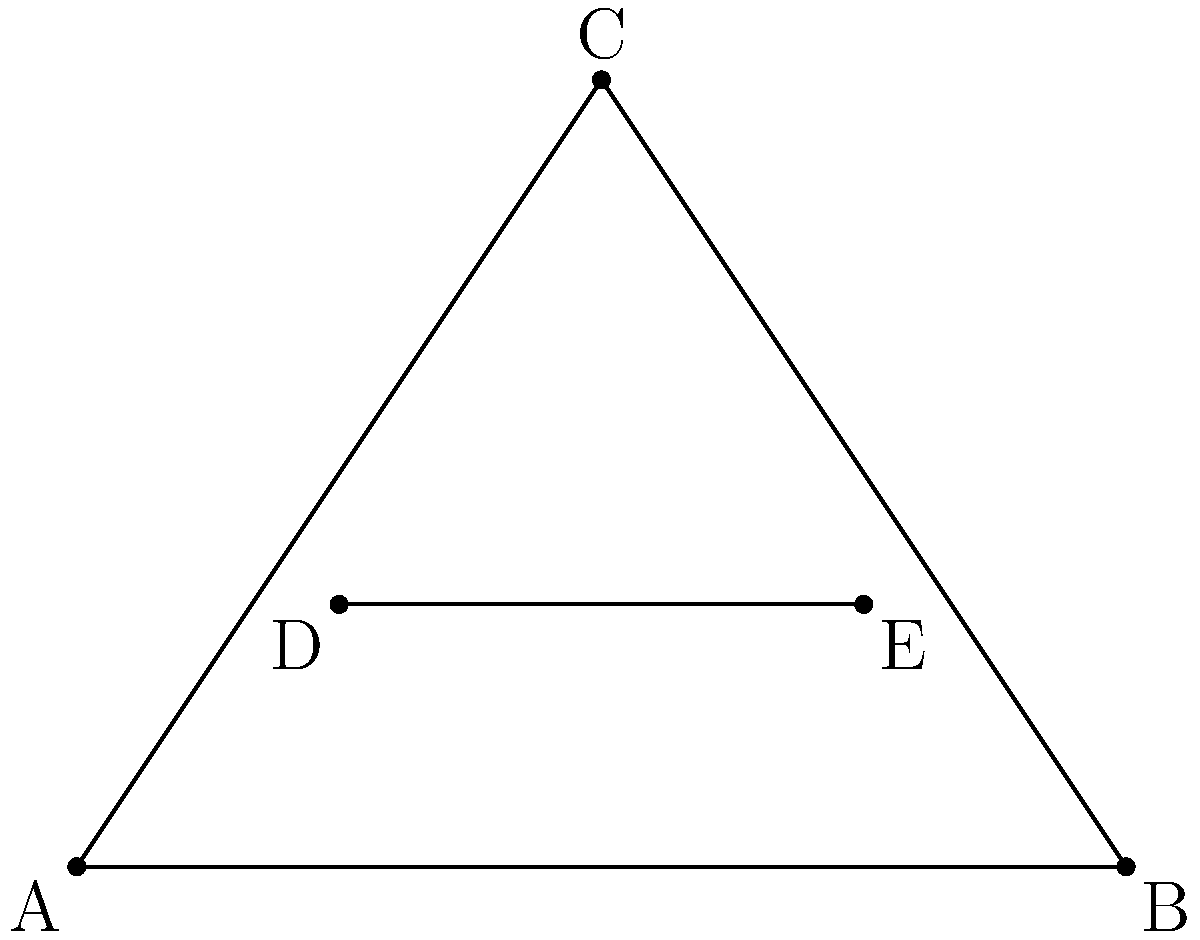Your spouse is excited about a geometry puzzle they found. They show you this diagram of a triangle with a line segment intersecting two of its sides and ask: "How many triangles are formed in this figure?" As a practical-minded person, how would you approach counting the triangles systematically to support your partner's interest? Let's approach this systematically:

1. First, identify the large triangle:
   - Triangle ABC (1 triangle)

2. Next, count the triangles formed by the intersecting line DE:
   - Triangle ADE
   - Triangle BDE
   - Triangle CDE
   (3 more triangles)

3. Now, count the triangles formed by combining parts of the original triangle with parts created by the intersecting line:
   - Triangle ACD
   - Triangle BCE
   (2 more triangles)

4. Finally, count the small triangles formed entirely within the original triangle:
   - Triangle CDE
   (1 more triangle)

5. Sum up all the triangles:
   $1 + 3 + 2 + 1 = 7$

By breaking down the problem into manageable steps, we can ensure we don't miss any triangles or count any twice.
Answer: 7 triangles 